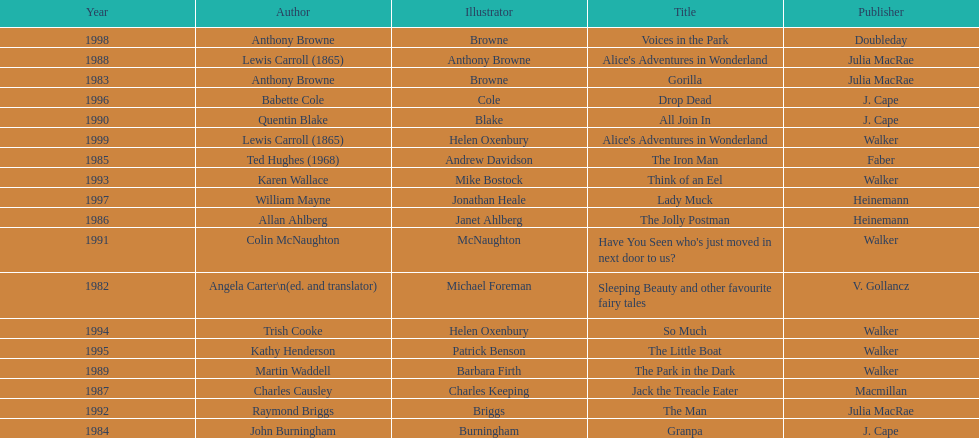How many number of titles are listed for the year 1991? 1. 